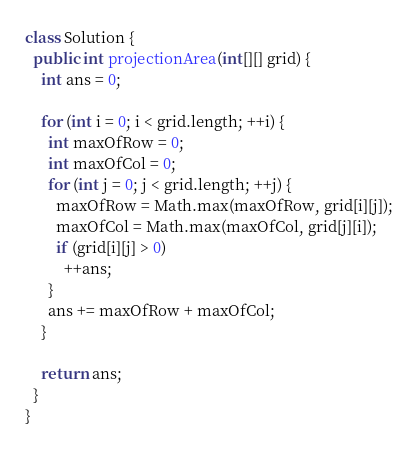Convert code to text. <code><loc_0><loc_0><loc_500><loc_500><_Java_>class Solution {
  public int projectionArea(int[][] grid) {
    int ans = 0;

    for (int i = 0; i < grid.length; ++i) {
      int maxOfRow = 0;
      int maxOfCol = 0;
      for (int j = 0; j < grid.length; ++j) {
        maxOfRow = Math.max(maxOfRow, grid[i][j]);
        maxOfCol = Math.max(maxOfCol, grid[j][i]);
        if (grid[i][j] > 0)
          ++ans;
      }
      ans += maxOfRow + maxOfCol;
    }

    return ans;
  }
}
</code> 